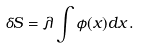Convert formula to latex. <formula><loc_0><loc_0><loc_500><loc_500>\delta S = \lambda \int \phi ( x ) d x \, .</formula> 